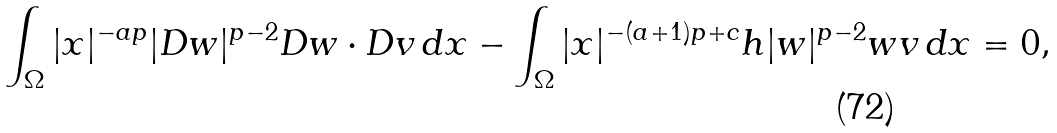Convert formula to latex. <formula><loc_0><loc_0><loc_500><loc_500>\int _ { \Omega } | x | ^ { - a p } | D w | ^ { p - 2 } D w \cdot D v \, d x - \int _ { \Omega } | x | ^ { - ( a + 1 ) p + c } h | w | ^ { p - 2 } w v \, d x = 0 ,</formula> 